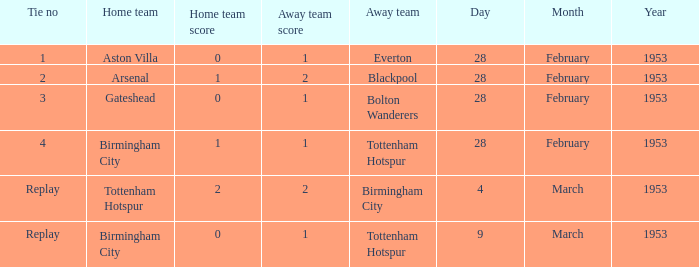Which Score has a Home team of aston villa? 0–1. 